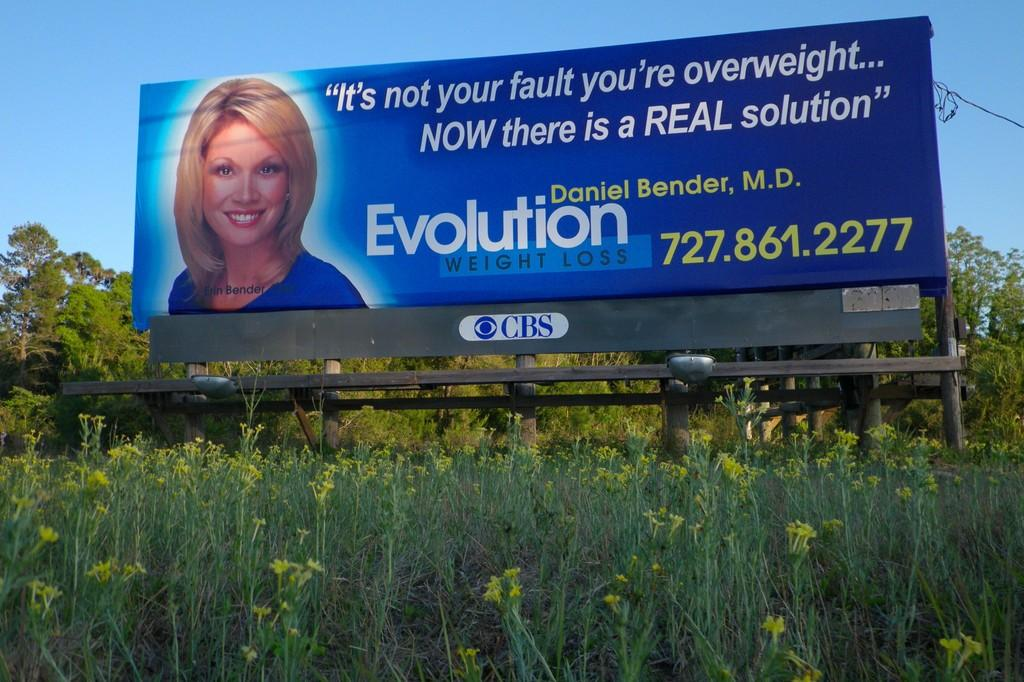<image>
Present a compact description of the photo's key features. An advertisement for Evolution Weight Loss shows a smiling woman next to the phone number. 